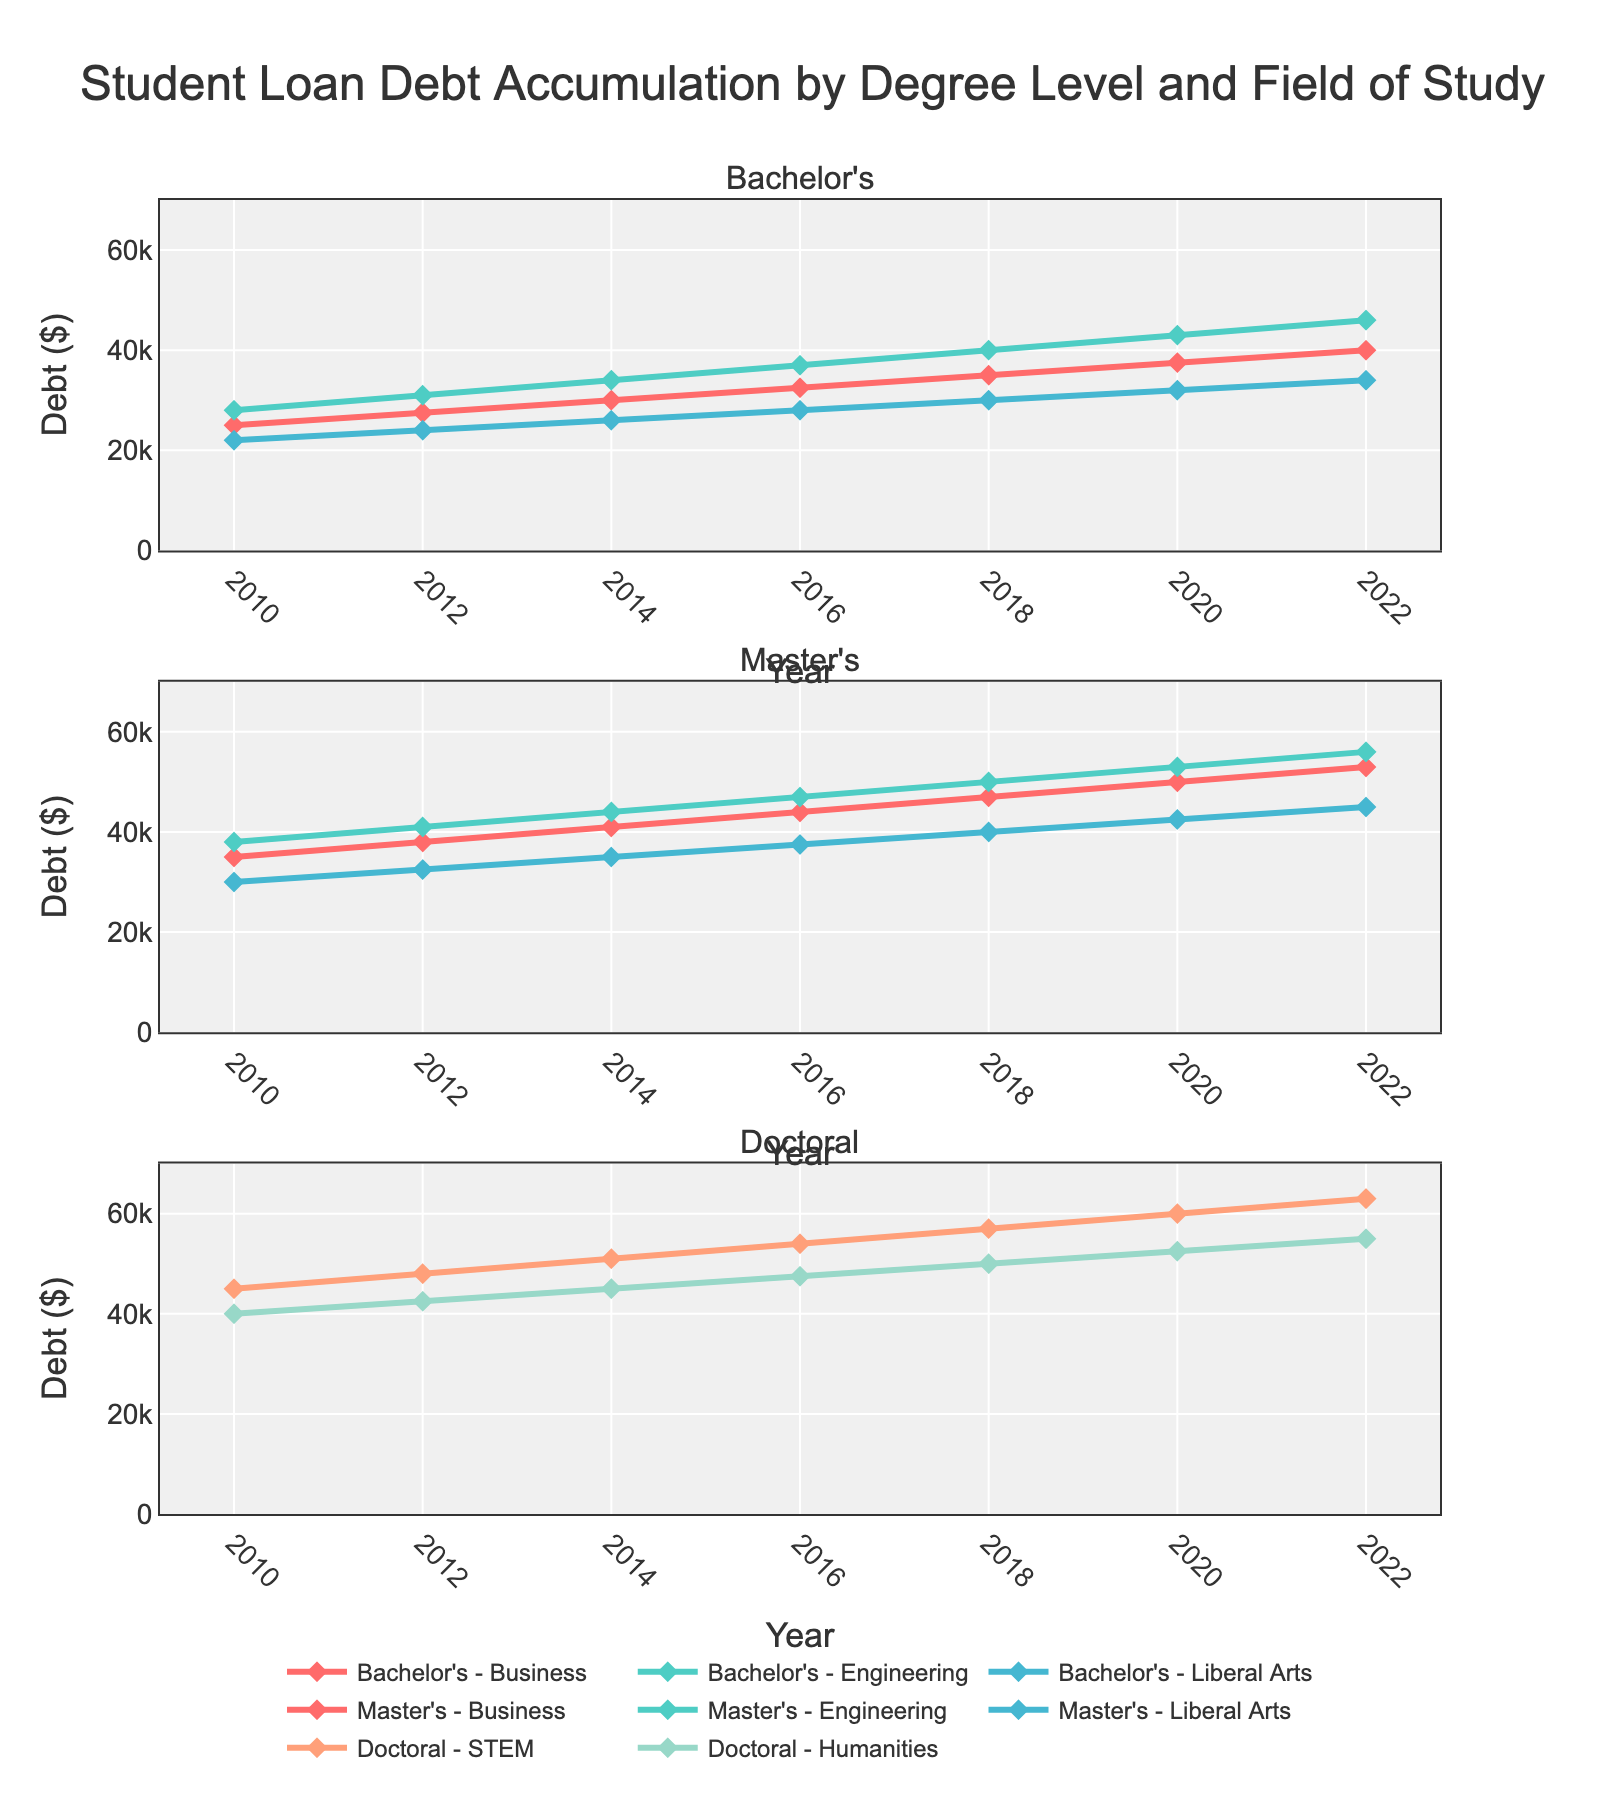what is the title of the plot? The title is located at the top of the plot, providing a concise description of what the plot represents. According to the provided code, the title of the plot is "Student Loan Debt Accumulation by Degree Level and Field of Study".
Answer: Student Loan Debt Accumulation by Degree Level and Field of Study What is the range of the y-axis? The range of the y-axis specifies the span of values represented on this axis, which measures the debt in dollars. The y-axis range is explicitly set in the code to go from 0 to 70,000.
Answer: 0 to 70000 Which subplots show data for master's degree levels? The plot is divided into three subplots, one for each degree level, labeled as subplots titles within the `subplot_titles` parameter. The master's data is shown in the second subplot.
Answer: The second subplot How does the debt accumulation for Bachelor's in Liberal Arts change from 2010 to 2022? To determine this, we look at the points corresponding to “Bachelor's - Liberal Arts” in the first subplot. The debt for Bachelor's in Liberal Arts starts at $22,000 in 2010 and increases to $34,000 in 2022.
Answer: $22,000 to $34,000 What field of study for Master's degree shows the highest debt in 2020? We look at the data points for the different fields in the second subplot for the year 2020 and compare their values. According to the data, Master's in Engineering has the highest debt at $53,000.
Answer: Master's in Engineering By how much did the student loan debt for Doctoral STEM increase from 2016 to 2022? We need to find the difference between the debt values for Doctoral STEM in 2022 and 2016 from the third subplot. In 2016, it was $54,000 and in 2022, it was $63,000. So, the increase is $63,000 - $54,000 = $9,000.
Answer: $9,000 Which degree level and field of study had the lowest student loan debt in 2012? We need to identify the smallest value among all fields across the first, second, and third subplots for the year 2012. From the data, the lowest debt in 2012 is for Bachelor's in Liberal Arts at $24,000.
Answer: Bachelor's in Liberal Arts Compare the debt trends for Bachelor's in Business and Master's in Business from 2010 to 2022. We need to examine the trends in both degree levels for the same field from the first and second subplots. Both degrees show a steadily increasing debt from 2010 to 2022. However, the increase for Master's in Business is more pronounced, starting at $35,000 in 2010 and reaching $53,000 in 2022, while Bachelor's in Business starts at $25,000 in 2010 and reaches $40,000 in 2022.
Answer: Both increase steadily; Master's has a steeper rise Which field of study shows a consistent increase in debt for all degree levels from 2010 to 2022? We observe the trends for each field across all three subplots in all degree levels from 2010 to 2022. Business shows a consistent increase in debt for Bachelor's, Master's, and Doctoral levels, indicating a steady upward trend across all degree stages.
Answer: Business 